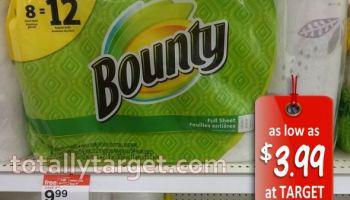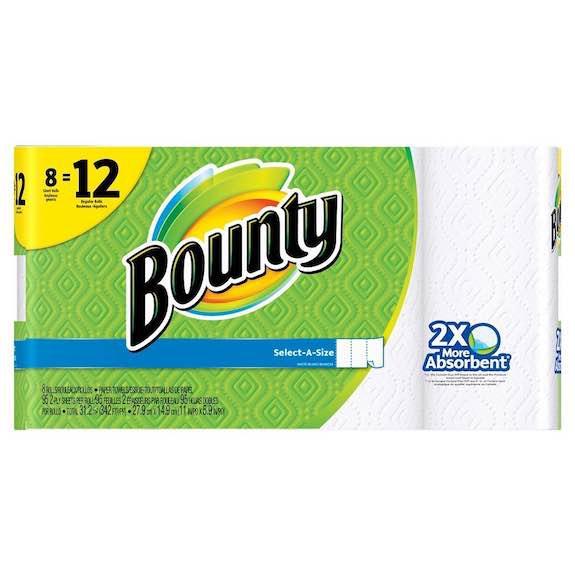The first image is the image on the left, the second image is the image on the right. For the images shown, is this caption "Right image shows a pack of paper towels on a store shelf with pegboard and a price sign visible." true? Answer yes or no. No. The first image is the image on the left, the second image is the image on the right. For the images shown, is this caption "In one of the images there is a single rectangular multi-pack of paper towels." true? Answer yes or no. Yes. 